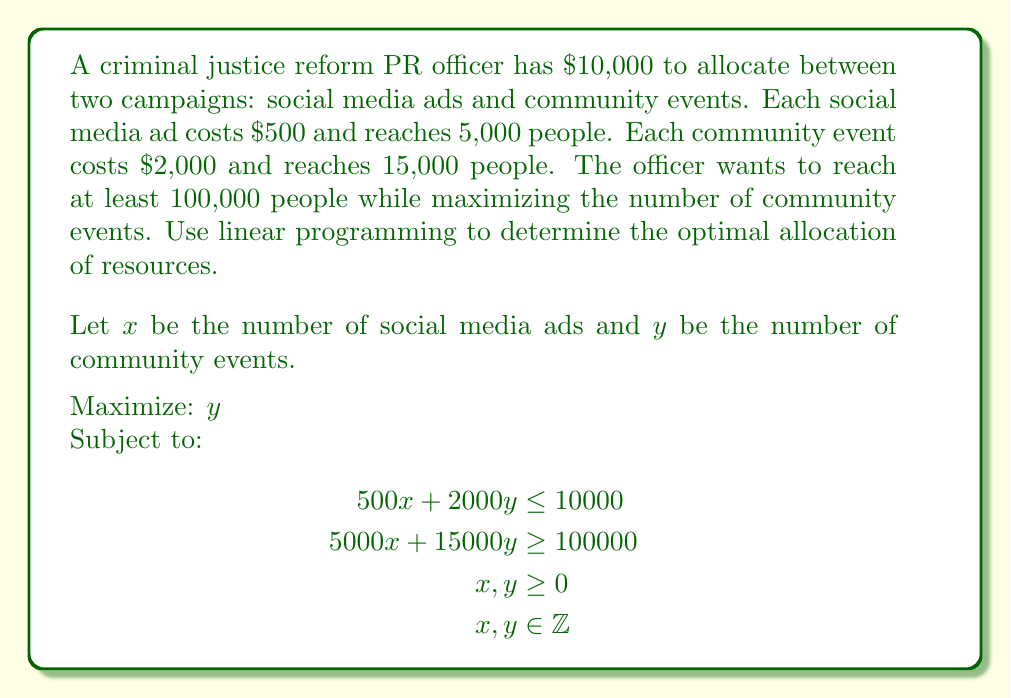Teach me how to tackle this problem. 1) First, we rewrite the constraints in standard form:
   $$\begin{align}
   500x + 2000y &\leq 10000 \\
   5000x + 15000y &\geq 100000 \\
   x, y &\geq 0 \\
   x, y &\in \mathbb{Z}
   \end{align}$$

2) We can graph these constraints:
   - Budget constraint: $y = 5 - 0.25x$
   - Reach constraint: $y = \frac{20}{3} - \frac{1}{3}x$

3) The feasible region is the area that satisfies both constraints. The optimal solution will be at one of the corner points of this region.

4) To find the corner points, we solve the system of equations:
   $$\begin{align}
   500x + 2000y &= 10000 \\
   5000x + 15000y &= 100000
   \end{align}$$

5) Solving this system:
   $x = 10$, $y = 2.5$

6) Since we need integer solutions, we round down to ensure we don't exceed the budget:
   $x = 10$, $y = 2$

7) We can verify this solution:
   - Budget: $500(10) + 2000(2) = 9000 \leq 10000$
   - Reach: $5000(10) + 15000(2) = 80000 \geq 100000$

8) This solution maximizes $y$ (number of community events) while satisfying all constraints.
Answer: 10 social media ads, 2 community events 